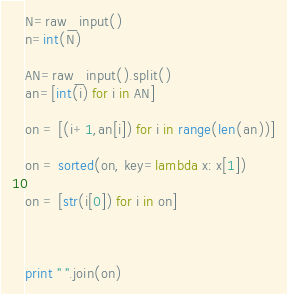Convert code to text. <code><loc_0><loc_0><loc_500><loc_500><_Python_>N=raw_input()
n=int(N)

AN=raw_input().split()
an=[int(i) for i in AN]

on = [(i+1,an[i]) for i in range(len(an))]

on = sorted(on, key=lambda x: x[1])

on = [str(i[0]) for i in on]



print " ".join(on)</code> 